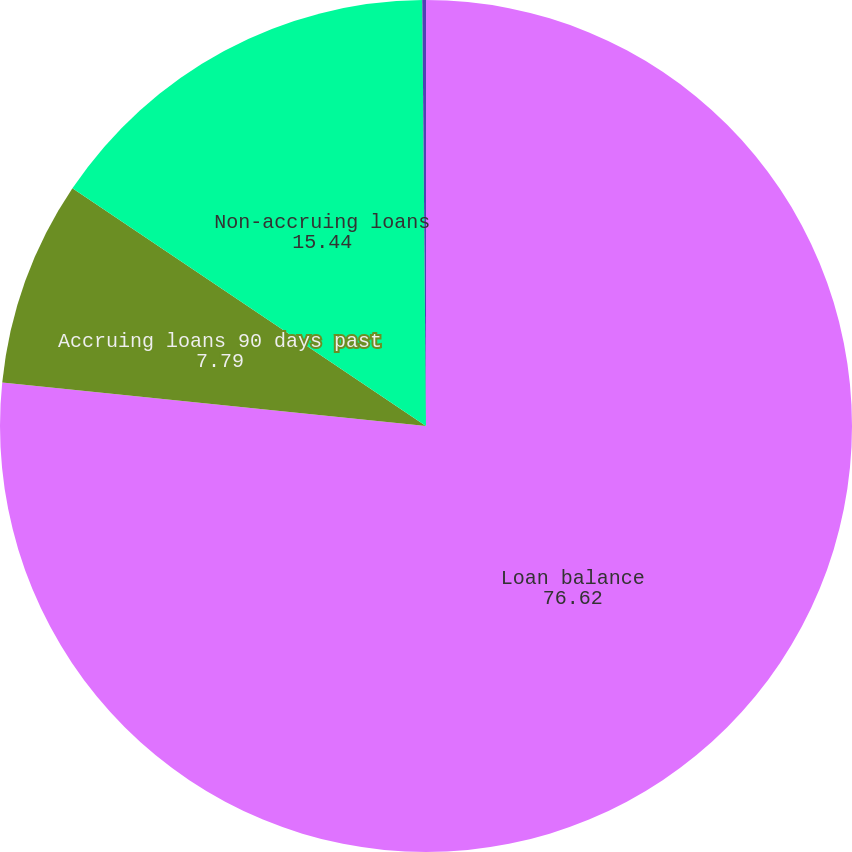Convert chart to OTSL. <chart><loc_0><loc_0><loc_500><loc_500><pie_chart><fcel>Loan balance<fcel>Accruing loans 90 days past<fcel>Non-accruing loans<fcel>Non-accruing<nl><fcel>76.62%<fcel>7.79%<fcel>15.44%<fcel>0.14%<nl></chart> 